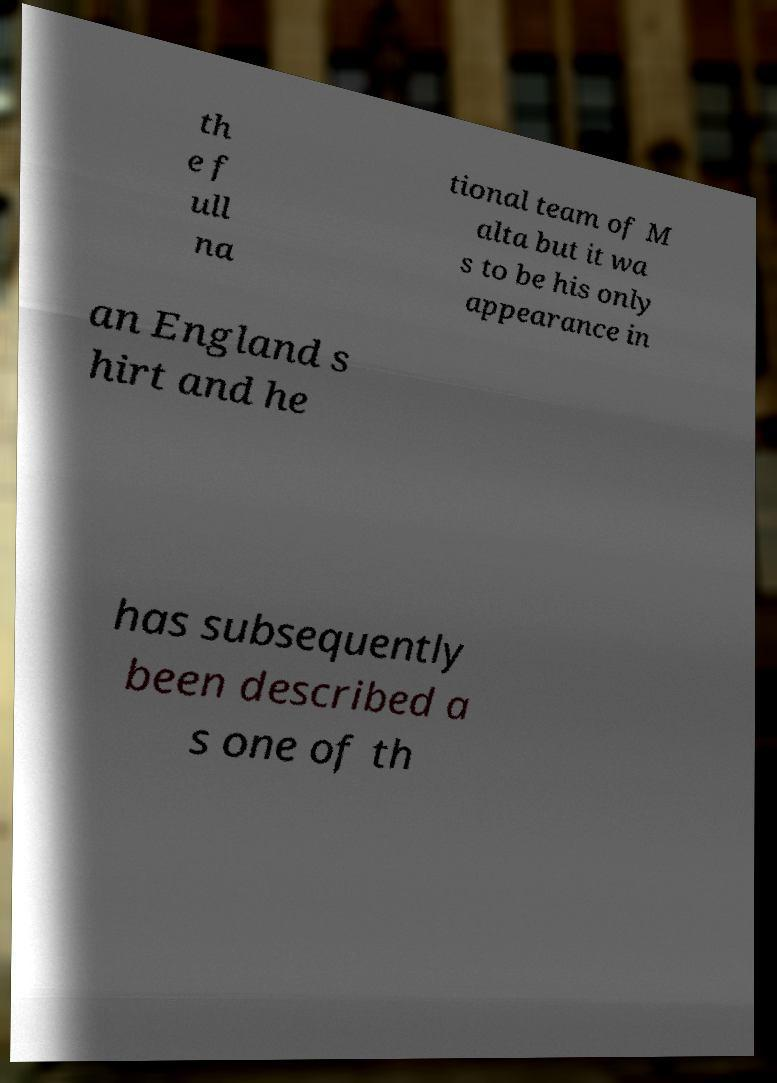Can you accurately transcribe the text from the provided image for me? th e f ull na tional team of M alta but it wa s to be his only appearance in an England s hirt and he has subsequently been described a s one of th 